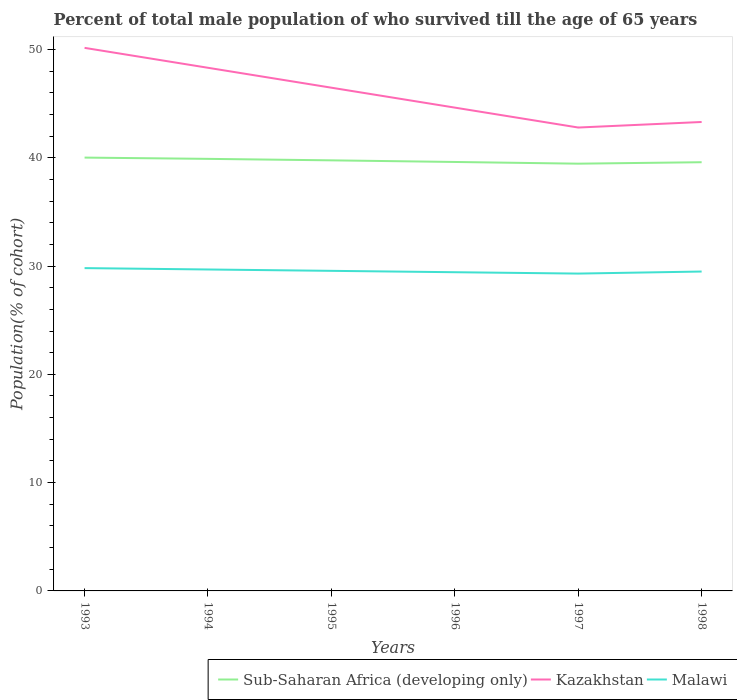Does the line corresponding to Kazakhstan intersect with the line corresponding to Malawi?
Your answer should be very brief. No. Is the number of lines equal to the number of legend labels?
Ensure brevity in your answer.  Yes. Across all years, what is the maximum percentage of total male population who survived till the age of 65 years in Kazakhstan?
Offer a terse response. 42.79. What is the total percentage of total male population who survived till the age of 65 years in Malawi in the graph?
Your answer should be compact. 0.13. What is the difference between the highest and the second highest percentage of total male population who survived till the age of 65 years in Kazakhstan?
Ensure brevity in your answer.  7.36. What is the difference between the highest and the lowest percentage of total male population who survived till the age of 65 years in Kazakhstan?
Your answer should be very brief. 3. Are the values on the major ticks of Y-axis written in scientific E-notation?
Make the answer very short. No. Does the graph contain any zero values?
Your answer should be compact. No. Does the graph contain grids?
Keep it short and to the point. No. Where does the legend appear in the graph?
Your answer should be compact. Bottom right. How many legend labels are there?
Your answer should be very brief. 3. How are the legend labels stacked?
Your response must be concise. Horizontal. What is the title of the graph?
Offer a terse response. Percent of total male population of who survived till the age of 65 years. Does "United Kingdom" appear as one of the legend labels in the graph?
Offer a terse response. No. What is the label or title of the Y-axis?
Provide a short and direct response. Population(% of cohort). What is the Population(% of cohort) of Sub-Saharan Africa (developing only) in 1993?
Your answer should be very brief. 40.01. What is the Population(% of cohort) of Kazakhstan in 1993?
Provide a succinct answer. 50.15. What is the Population(% of cohort) in Malawi in 1993?
Your answer should be compact. 29.81. What is the Population(% of cohort) of Sub-Saharan Africa (developing only) in 1994?
Your answer should be compact. 39.9. What is the Population(% of cohort) in Kazakhstan in 1994?
Give a very brief answer. 48.31. What is the Population(% of cohort) in Malawi in 1994?
Provide a succinct answer. 29.68. What is the Population(% of cohort) of Sub-Saharan Africa (developing only) in 1995?
Provide a succinct answer. 39.76. What is the Population(% of cohort) of Kazakhstan in 1995?
Ensure brevity in your answer.  46.47. What is the Population(% of cohort) of Malawi in 1995?
Offer a terse response. 29.55. What is the Population(% of cohort) in Sub-Saharan Africa (developing only) in 1996?
Your answer should be compact. 39.61. What is the Population(% of cohort) of Kazakhstan in 1996?
Keep it short and to the point. 44.63. What is the Population(% of cohort) of Malawi in 1996?
Provide a short and direct response. 29.43. What is the Population(% of cohort) in Sub-Saharan Africa (developing only) in 1997?
Give a very brief answer. 39.45. What is the Population(% of cohort) of Kazakhstan in 1997?
Provide a short and direct response. 42.79. What is the Population(% of cohort) in Malawi in 1997?
Make the answer very short. 29.3. What is the Population(% of cohort) of Sub-Saharan Africa (developing only) in 1998?
Keep it short and to the point. 39.59. What is the Population(% of cohort) in Kazakhstan in 1998?
Give a very brief answer. 43.3. What is the Population(% of cohort) in Malawi in 1998?
Make the answer very short. 29.49. Across all years, what is the maximum Population(% of cohort) in Sub-Saharan Africa (developing only)?
Give a very brief answer. 40.01. Across all years, what is the maximum Population(% of cohort) of Kazakhstan?
Keep it short and to the point. 50.15. Across all years, what is the maximum Population(% of cohort) of Malawi?
Ensure brevity in your answer.  29.81. Across all years, what is the minimum Population(% of cohort) in Sub-Saharan Africa (developing only)?
Offer a terse response. 39.45. Across all years, what is the minimum Population(% of cohort) of Kazakhstan?
Give a very brief answer. 42.79. Across all years, what is the minimum Population(% of cohort) of Malawi?
Your response must be concise. 29.3. What is the total Population(% of cohort) in Sub-Saharan Africa (developing only) in the graph?
Your answer should be very brief. 238.31. What is the total Population(% of cohort) in Kazakhstan in the graph?
Keep it short and to the point. 275.64. What is the total Population(% of cohort) of Malawi in the graph?
Your answer should be very brief. 177.27. What is the difference between the Population(% of cohort) in Sub-Saharan Africa (developing only) in 1993 and that in 1994?
Your response must be concise. 0.12. What is the difference between the Population(% of cohort) of Kazakhstan in 1993 and that in 1994?
Your response must be concise. 1.84. What is the difference between the Population(% of cohort) in Malawi in 1993 and that in 1994?
Make the answer very short. 0.13. What is the difference between the Population(% of cohort) of Sub-Saharan Africa (developing only) in 1993 and that in 1995?
Make the answer very short. 0.25. What is the difference between the Population(% of cohort) in Kazakhstan in 1993 and that in 1995?
Ensure brevity in your answer.  3.68. What is the difference between the Population(% of cohort) of Malawi in 1993 and that in 1995?
Keep it short and to the point. 0.25. What is the difference between the Population(% of cohort) of Sub-Saharan Africa (developing only) in 1993 and that in 1996?
Provide a short and direct response. 0.4. What is the difference between the Population(% of cohort) of Kazakhstan in 1993 and that in 1996?
Offer a terse response. 5.52. What is the difference between the Population(% of cohort) in Malawi in 1993 and that in 1996?
Offer a terse response. 0.38. What is the difference between the Population(% of cohort) of Sub-Saharan Africa (developing only) in 1993 and that in 1997?
Make the answer very short. 0.56. What is the difference between the Population(% of cohort) of Kazakhstan in 1993 and that in 1997?
Offer a very short reply. 7.36. What is the difference between the Population(% of cohort) of Malawi in 1993 and that in 1997?
Your answer should be very brief. 0.51. What is the difference between the Population(% of cohort) in Sub-Saharan Africa (developing only) in 1993 and that in 1998?
Provide a succinct answer. 0.43. What is the difference between the Population(% of cohort) of Kazakhstan in 1993 and that in 1998?
Provide a short and direct response. 6.84. What is the difference between the Population(% of cohort) in Malawi in 1993 and that in 1998?
Offer a terse response. 0.32. What is the difference between the Population(% of cohort) of Sub-Saharan Africa (developing only) in 1994 and that in 1995?
Your response must be concise. 0.14. What is the difference between the Population(% of cohort) of Kazakhstan in 1994 and that in 1995?
Give a very brief answer. 1.84. What is the difference between the Population(% of cohort) in Malawi in 1994 and that in 1995?
Provide a short and direct response. 0.13. What is the difference between the Population(% of cohort) in Sub-Saharan Africa (developing only) in 1994 and that in 1996?
Keep it short and to the point. 0.29. What is the difference between the Population(% of cohort) of Kazakhstan in 1994 and that in 1996?
Provide a short and direct response. 3.68. What is the difference between the Population(% of cohort) of Malawi in 1994 and that in 1996?
Give a very brief answer. 0.25. What is the difference between the Population(% of cohort) of Sub-Saharan Africa (developing only) in 1994 and that in 1997?
Your answer should be very brief. 0.44. What is the difference between the Population(% of cohort) in Kazakhstan in 1994 and that in 1997?
Offer a very short reply. 5.52. What is the difference between the Population(% of cohort) in Malawi in 1994 and that in 1997?
Provide a short and direct response. 0.38. What is the difference between the Population(% of cohort) in Sub-Saharan Africa (developing only) in 1994 and that in 1998?
Offer a very short reply. 0.31. What is the difference between the Population(% of cohort) of Kazakhstan in 1994 and that in 1998?
Provide a succinct answer. 5.01. What is the difference between the Population(% of cohort) in Malawi in 1994 and that in 1998?
Your answer should be very brief. 0.19. What is the difference between the Population(% of cohort) in Sub-Saharan Africa (developing only) in 1995 and that in 1996?
Offer a very short reply. 0.15. What is the difference between the Population(% of cohort) in Kazakhstan in 1995 and that in 1996?
Provide a succinct answer. 1.84. What is the difference between the Population(% of cohort) in Malawi in 1995 and that in 1996?
Ensure brevity in your answer.  0.13. What is the difference between the Population(% of cohort) of Sub-Saharan Africa (developing only) in 1995 and that in 1997?
Your answer should be very brief. 0.31. What is the difference between the Population(% of cohort) in Kazakhstan in 1995 and that in 1997?
Give a very brief answer. 3.68. What is the difference between the Population(% of cohort) of Malawi in 1995 and that in 1997?
Your response must be concise. 0.25. What is the difference between the Population(% of cohort) of Sub-Saharan Africa (developing only) in 1995 and that in 1998?
Offer a very short reply. 0.17. What is the difference between the Population(% of cohort) in Kazakhstan in 1995 and that in 1998?
Offer a terse response. 3.17. What is the difference between the Population(% of cohort) in Malawi in 1995 and that in 1998?
Provide a succinct answer. 0.06. What is the difference between the Population(% of cohort) in Sub-Saharan Africa (developing only) in 1996 and that in 1997?
Your answer should be compact. 0.16. What is the difference between the Population(% of cohort) in Kazakhstan in 1996 and that in 1997?
Provide a succinct answer. 1.84. What is the difference between the Population(% of cohort) of Malawi in 1996 and that in 1997?
Ensure brevity in your answer.  0.13. What is the difference between the Population(% of cohort) of Sub-Saharan Africa (developing only) in 1996 and that in 1998?
Offer a terse response. 0.02. What is the difference between the Population(% of cohort) in Kazakhstan in 1996 and that in 1998?
Make the answer very short. 1.33. What is the difference between the Population(% of cohort) of Malawi in 1996 and that in 1998?
Provide a succinct answer. -0.06. What is the difference between the Population(% of cohort) in Sub-Saharan Africa (developing only) in 1997 and that in 1998?
Ensure brevity in your answer.  -0.14. What is the difference between the Population(% of cohort) of Kazakhstan in 1997 and that in 1998?
Give a very brief answer. -0.51. What is the difference between the Population(% of cohort) of Malawi in 1997 and that in 1998?
Your answer should be very brief. -0.19. What is the difference between the Population(% of cohort) of Sub-Saharan Africa (developing only) in 1993 and the Population(% of cohort) of Kazakhstan in 1994?
Offer a very short reply. -8.29. What is the difference between the Population(% of cohort) of Sub-Saharan Africa (developing only) in 1993 and the Population(% of cohort) of Malawi in 1994?
Offer a very short reply. 10.33. What is the difference between the Population(% of cohort) in Kazakhstan in 1993 and the Population(% of cohort) in Malawi in 1994?
Offer a terse response. 20.46. What is the difference between the Population(% of cohort) in Sub-Saharan Africa (developing only) in 1993 and the Population(% of cohort) in Kazakhstan in 1995?
Offer a terse response. -6.45. What is the difference between the Population(% of cohort) in Sub-Saharan Africa (developing only) in 1993 and the Population(% of cohort) in Malawi in 1995?
Give a very brief answer. 10.46. What is the difference between the Population(% of cohort) in Kazakhstan in 1993 and the Population(% of cohort) in Malawi in 1995?
Your answer should be compact. 20.59. What is the difference between the Population(% of cohort) in Sub-Saharan Africa (developing only) in 1993 and the Population(% of cohort) in Kazakhstan in 1996?
Provide a succinct answer. -4.62. What is the difference between the Population(% of cohort) of Sub-Saharan Africa (developing only) in 1993 and the Population(% of cohort) of Malawi in 1996?
Offer a very short reply. 10.58. What is the difference between the Population(% of cohort) of Kazakhstan in 1993 and the Population(% of cohort) of Malawi in 1996?
Keep it short and to the point. 20.72. What is the difference between the Population(% of cohort) of Sub-Saharan Africa (developing only) in 1993 and the Population(% of cohort) of Kazakhstan in 1997?
Your answer should be very brief. -2.78. What is the difference between the Population(% of cohort) in Sub-Saharan Africa (developing only) in 1993 and the Population(% of cohort) in Malawi in 1997?
Your answer should be very brief. 10.71. What is the difference between the Population(% of cohort) in Kazakhstan in 1993 and the Population(% of cohort) in Malawi in 1997?
Provide a succinct answer. 20.84. What is the difference between the Population(% of cohort) of Sub-Saharan Africa (developing only) in 1993 and the Population(% of cohort) of Kazakhstan in 1998?
Your answer should be very brief. -3.29. What is the difference between the Population(% of cohort) in Sub-Saharan Africa (developing only) in 1993 and the Population(% of cohort) in Malawi in 1998?
Keep it short and to the point. 10.52. What is the difference between the Population(% of cohort) of Kazakhstan in 1993 and the Population(% of cohort) of Malawi in 1998?
Give a very brief answer. 20.65. What is the difference between the Population(% of cohort) of Sub-Saharan Africa (developing only) in 1994 and the Population(% of cohort) of Kazakhstan in 1995?
Make the answer very short. -6.57. What is the difference between the Population(% of cohort) of Sub-Saharan Africa (developing only) in 1994 and the Population(% of cohort) of Malawi in 1995?
Your answer should be compact. 10.34. What is the difference between the Population(% of cohort) in Kazakhstan in 1994 and the Population(% of cohort) in Malawi in 1995?
Your response must be concise. 18.75. What is the difference between the Population(% of cohort) in Sub-Saharan Africa (developing only) in 1994 and the Population(% of cohort) in Kazakhstan in 1996?
Give a very brief answer. -4.73. What is the difference between the Population(% of cohort) in Sub-Saharan Africa (developing only) in 1994 and the Population(% of cohort) in Malawi in 1996?
Your answer should be compact. 10.47. What is the difference between the Population(% of cohort) in Kazakhstan in 1994 and the Population(% of cohort) in Malawi in 1996?
Offer a very short reply. 18.88. What is the difference between the Population(% of cohort) of Sub-Saharan Africa (developing only) in 1994 and the Population(% of cohort) of Kazakhstan in 1997?
Keep it short and to the point. -2.89. What is the difference between the Population(% of cohort) of Sub-Saharan Africa (developing only) in 1994 and the Population(% of cohort) of Malawi in 1997?
Offer a terse response. 10.59. What is the difference between the Population(% of cohort) of Kazakhstan in 1994 and the Population(% of cohort) of Malawi in 1997?
Give a very brief answer. 19. What is the difference between the Population(% of cohort) in Sub-Saharan Africa (developing only) in 1994 and the Population(% of cohort) in Kazakhstan in 1998?
Give a very brief answer. -3.41. What is the difference between the Population(% of cohort) in Sub-Saharan Africa (developing only) in 1994 and the Population(% of cohort) in Malawi in 1998?
Provide a short and direct response. 10.4. What is the difference between the Population(% of cohort) of Kazakhstan in 1994 and the Population(% of cohort) of Malawi in 1998?
Offer a very short reply. 18.81. What is the difference between the Population(% of cohort) in Sub-Saharan Africa (developing only) in 1995 and the Population(% of cohort) in Kazakhstan in 1996?
Offer a very short reply. -4.87. What is the difference between the Population(% of cohort) in Sub-Saharan Africa (developing only) in 1995 and the Population(% of cohort) in Malawi in 1996?
Make the answer very short. 10.33. What is the difference between the Population(% of cohort) of Kazakhstan in 1995 and the Population(% of cohort) of Malawi in 1996?
Provide a short and direct response. 17.04. What is the difference between the Population(% of cohort) in Sub-Saharan Africa (developing only) in 1995 and the Population(% of cohort) in Kazakhstan in 1997?
Make the answer very short. -3.03. What is the difference between the Population(% of cohort) in Sub-Saharan Africa (developing only) in 1995 and the Population(% of cohort) in Malawi in 1997?
Your answer should be compact. 10.46. What is the difference between the Population(% of cohort) of Kazakhstan in 1995 and the Population(% of cohort) of Malawi in 1997?
Make the answer very short. 17.16. What is the difference between the Population(% of cohort) in Sub-Saharan Africa (developing only) in 1995 and the Population(% of cohort) in Kazakhstan in 1998?
Provide a short and direct response. -3.54. What is the difference between the Population(% of cohort) in Sub-Saharan Africa (developing only) in 1995 and the Population(% of cohort) in Malawi in 1998?
Make the answer very short. 10.27. What is the difference between the Population(% of cohort) of Kazakhstan in 1995 and the Population(% of cohort) of Malawi in 1998?
Keep it short and to the point. 16.98. What is the difference between the Population(% of cohort) in Sub-Saharan Africa (developing only) in 1996 and the Population(% of cohort) in Kazakhstan in 1997?
Make the answer very short. -3.18. What is the difference between the Population(% of cohort) of Sub-Saharan Africa (developing only) in 1996 and the Population(% of cohort) of Malawi in 1997?
Offer a terse response. 10.31. What is the difference between the Population(% of cohort) in Kazakhstan in 1996 and the Population(% of cohort) in Malawi in 1997?
Ensure brevity in your answer.  15.33. What is the difference between the Population(% of cohort) of Sub-Saharan Africa (developing only) in 1996 and the Population(% of cohort) of Kazakhstan in 1998?
Offer a very short reply. -3.69. What is the difference between the Population(% of cohort) of Sub-Saharan Africa (developing only) in 1996 and the Population(% of cohort) of Malawi in 1998?
Provide a short and direct response. 10.12. What is the difference between the Population(% of cohort) in Kazakhstan in 1996 and the Population(% of cohort) in Malawi in 1998?
Make the answer very short. 15.14. What is the difference between the Population(% of cohort) of Sub-Saharan Africa (developing only) in 1997 and the Population(% of cohort) of Kazakhstan in 1998?
Offer a very short reply. -3.85. What is the difference between the Population(% of cohort) in Sub-Saharan Africa (developing only) in 1997 and the Population(% of cohort) in Malawi in 1998?
Keep it short and to the point. 9.96. What is the difference between the Population(% of cohort) of Kazakhstan in 1997 and the Population(% of cohort) of Malawi in 1998?
Give a very brief answer. 13.3. What is the average Population(% of cohort) in Sub-Saharan Africa (developing only) per year?
Your answer should be very brief. 39.72. What is the average Population(% of cohort) of Kazakhstan per year?
Your answer should be compact. 45.94. What is the average Population(% of cohort) in Malawi per year?
Your answer should be compact. 29.54. In the year 1993, what is the difference between the Population(% of cohort) of Sub-Saharan Africa (developing only) and Population(% of cohort) of Kazakhstan?
Give a very brief answer. -10.13. In the year 1993, what is the difference between the Population(% of cohort) of Sub-Saharan Africa (developing only) and Population(% of cohort) of Malawi?
Provide a short and direct response. 10.21. In the year 1993, what is the difference between the Population(% of cohort) in Kazakhstan and Population(% of cohort) in Malawi?
Provide a short and direct response. 20.34. In the year 1994, what is the difference between the Population(% of cohort) in Sub-Saharan Africa (developing only) and Population(% of cohort) in Kazakhstan?
Ensure brevity in your answer.  -8.41. In the year 1994, what is the difference between the Population(% of cohort) in Sub-Saharan Africa (developing only) and Population(% of cohort) in Malawi?
Your answer should be very brief. 10.21. In the year 1994, what is the difference between the Population(% of cohort) in Kazakhstan and Population(% of cohort) in Malawi?
Provide a short and direct response. 18.62. In the year 1995, what is the difference between the Population(% of cohort) in Sub-Saharan Africa (developing only) and Population(% of cohort) in Kazakhstan?
Provide a succinct answer. -6.71. In the year 1995, what is the difference between the Population(% of cohort) in Sub-Saharan Africa (developing only) and Population(% of cohort) in Malawi?
Provide a succinct answer. 10.2. In the year 1995, what is the difference between the Population(% of cohort) in Kazakhstan and Population(% of cohort) in Malawi?
Your answer should be very brief. 16.91. In the year 1996, what is the difference between the Population(% of cohort) of Sub-Saharan Africa (developing only) and Population(% of cohort) of Kazakhstan?
Give a very brief answer. -5.02. In the year 1996, what is the difference between the Population(% of cohort) of Sub-Saharan Africa (developing only) and Population(% of cohort) of Malawi?
Ensure brevity in your answer.  10.18. In the year 1996, what is the difference between the Population(% of cohort) of Kazakhstan and Population(% of cohort) of Malawi?
Your answer should be very brief. 15.2. In the year 1997, what is the difference between the Population(% of cohort) in Sub-Saharan Africa (developing only) and Population(% of cohort) in Kazakhstan?
Your response must be concise. -3.34. In the year 1997, what is the difference between the Population(% of cohort) in Sub-Saharan Africa (developing only) and Population(% of cohort) in Malawi?
Your answer should be compact. 10.15. In the year 1997, what is the difference between the Population(% of cohort) of Kazakhstan and Population(% of cohort) of Malawi?
Provide a succinct answer. 13.49. In the year 1998, what is the difference between the Population(% of cohort) in Sub-Saharan Africa (developing only) and Population(% of cohort) in Kazakhstan?
Offer a very short reply. -3.71. In the year 1998, what is the difference between the Population(% of cohort) in Sub-Saharan Africa (developing only) and Population(% of cohort) in Malawi?
Provide a succinct answer. 10.09. In the year 1998, what is the difference between the Population(% of cohort) in Kazakhstan and Population(% of cohort) in Malawi?
Offer a terse response. 13.81. What is the ratio of the Population(% of cohort) in Sub-Saharan Africa (developing only) in 1993 to that in 1994?
Your answer should be compact. 1. What is the ratio of the Population(% of cohort) of Kazakhstan in 1993 to that in 1994?
Keep it short and to the point. 1.04. What is the ratio of the Population(% of cohort) in Sub-Saharan Africa (developing only) in 1993 to that in 1995?
Give a very brief answer. 1.01. What is the ratio of the Population(% of cohort) of Kazakhstan in 1993 to that in 1995?
Your answer should be very brief. 1.08. What is the ratio of the Population(% of cohort) of Malawi in 1993 to that in 1995?
Your answer should be compact. 1.01. What is the ratio of the Population(% of cohort) in Sub-Saharan Africa (developing only) in 1993 to that in 1996?
Provide a succinct answer. 1.01. What is the ratio of the Population(% of cohort) of Kazakhstan in 1993 to that in 1996?
Provide a succinct answer. 1.12. What is the ratio of the Population(% of cohort) of Malawi in 1993 to that in 1996?
Provide a succinct answer. 1.01. What is the ratio of the Population(% of cohort) in Sub-Saharan Africa (developing only) in 1993 to that in 1997?
Your response must be concise. 1.01. What is the ratio of the Population(% of cohort) in Kazakhstan in 1993 to that in 1997?
Ensure brevity in your answer.  1.17. What is the ratio of the Population(% of cohort) in Malawi in 1993 to that in 1997?
Offer a very short reply. 1.02. What is the ratio of the Population(% of cohort) in Sub-Saharan Africa (developing only) in 1993 to that in 1998?
Keep it short and to the point. 1.01. What is the ratio of the Population(% of cohort) of Kazakhstan in 1993 to that in 1998?
Keep it short and to the point. 1.16. What is the ratio of the Population(% of cohort) of Malawi in 1993 to that in 1998?
Ensure brevity in your answer.  1.01. What is the ratio of the Population(% of cohort) of Sub-Saharan Africa (developing only) in 1994 to that in 1995?
Ensure brevity in your answer.  1. What is the ratio of the Population(% of cohort) of Kazakhstan in 1994 to that in 1995?
Provide a short and direct response. 1.04. What is the ratio of the Population(% of cohort) in Malawi in 1994 to that in 1995?
Your answer should be very brief. 1. What is the ratio of the Population(% of cohort) of Kazakhstan in 1994 to that in 1996?
Give a very brief answer. 1.08. What is the ratio of the Population(% of cohort) of Malawi in 1994 to that in 1996?
Make the answer very short. 1.01. What is the ratio of the Population(% of cohort) of Sub-Saharan Africa (developing only) in 1994 to that in 1997?
Your answer should be compact. 1.01. What is the ratio of the Population(% of cohort) in Kazakhstan in 1994 to that in 1997?
Offer a very short reply. 1.13. What is the ratio of the Population(% of cohort) of Malawi in 1994 to that in 1997?
Keep it short and to the point. 1.01. What is the ratio of the Population(% of cohort) in Sub-Saharan Africa (developing only) in 1994 to that in 1998?
Ensure brevity in your answer.  1.01. What is the ratio of the Population(% of cohort) of Kazakhstan in 1994 to that in 1998?
Provide a short and direct response. 1.12. What is the ratio of the Population(% of cohort) in Malawi in 1994 to that in 1998?
Ensure brevity in your answer.  1.01. What is the ratio of the Population(% of cohort) in Kazakhstan in 1995 to that in 1996?
Keep it short and to the point. 1.04. What is the ratio of the Population(% of cohort) in Sub-Saharan Africa (developing only) in 1995 to that in 1997?
Provide a succinct answer. 1.01. What is the ratio of the Population(% of cohort) of Kazakhstan in 1995 to that in 1997?
Your answer should be compact. 1.09. What is the ratio of the Population(% of cohort) in Malawi in 1995 to that in 1997?
Provide a succinct answer. 1.01. What is the ratio of the Population(% of cohort) in Kazakhstan in 1995 to that in 1998?
Your answer should be compact. 1.07. What is the ratio of the Population(% of cohort) of Malawi in 1995 to that in 1998?
Provide a short and direct response. 1. What is the ratio of the Population(% of cohort) in Kazakhstan in 1996 to that in 1997?
Provide a short and direct response. 1.04. What is the ratio of the Population(% of cohort) of Sub-Saharan Africa (developing only) in 1996 to that in 1998?
Offer a very short reply. 1. What is the ratio of the Population(% of cohort) in Kazakhstan in 1996 to that in 1998?
Provide a short and direct response. 1.03. What is the ratio of the Population(% of cohort) of Malawi in 1996 to that in 1998?
Your response must be concise. 1. What is the ratio of the Population(% of cohort) of Sub-Saharan Africa (developing only) in 1997 to that in 1998?
Offer a very short reply. 1. What is the ratio of the Population(% of cohort) of Kazakhstan in 1997 to that in 1998?
Your answer should be compact. 0.99. What is the difference between the highest and the second highest Population(% of cohort) in Sub-Saharan Africa (developing only)?
Your response must be concise. 0.12. What is the difference between the highest and the second highest Population(% of cohort) in Kazakhstan?
Your answer should be very brief. 1.84. What is the difference between the highest and the second highest Population(% of cohort) of Malawi?
Offer a very short reply. 0.13. What is the difference between the highest and the lowest Population(% of cohort) in Sub-Saharan Africa (developing only)?
Ensure brevity in your answer.  0.56. What is the difference between the highest and the lowest Population(% of cohort) in Kazakhstan?
Keep it short and to the point. 7.36. What is the difference between the highest and the lowest Population(% of cohort) of Malawi?
Provide a short and direct response. 0.51. 